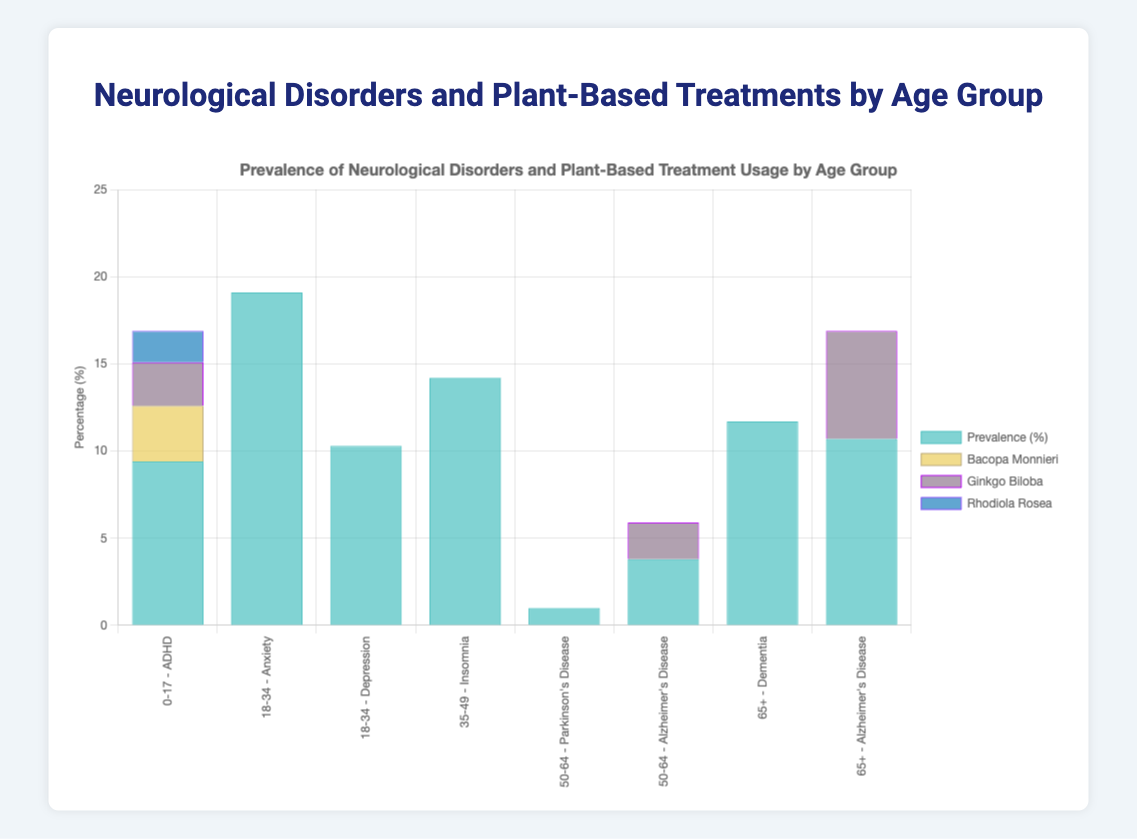What is the prevalence (%) of Anxiety in the 18-34 age group? Look at the bar corresponding to the 18-34 age group with the label "Anxiety." The height of the blue section of the bar indicates the prevalence.
Answer: 19.1 Which disorder has the highest plant-based treatment usage rate in the 50-64 age group? Compare the different treatment usage rates within the three plant-based compounds for the age group 50-64. The tallest segment in these bars corresponds to Ginkgo Biloba for Alzheimer's Disease.
Answer: Ginkgo Biloba for Alzheimer's Disease What is the total plant-based treatment usage (%) for ADHD in the 0-17 age group? Add up the individual percentages for Bacopa Monnieri, Ginkgo Biloba, and Rhodiola Rosea in the 0-17 age group. 3.2 + 2.5 + 1.8 = 7.5.
Answer: 7.5 In the 65+ age group, which plant-based treatment is used more for Alzheimer's Disease, Ginkgo Biloba or Huperzine A? Look at the respective segments for Ginkgo Biloba and Huperzine A within the 65+ age group bar for Alzheimer's Disease. The blue section (Ginkgo Biloba) is higher.
Answer: Ginkgo Biloba What is the difference in the prevalence (%) of Alzheimer's Disease between the 50-64 and 65+ age groups? Subtract the prevalence rate for the 50-64 age group from that of the 65+ age group. 10.7 - 3.8 = 6.9.
Answer: 6.9 Which plant-based treatment has the highest usage (%) for Anxiety in the 18-34 age group? Compare the heights of the segments within the Anxiety bar for the 18-34 age group. The tallest section (8.3) corresponds to Ashwagandha.
Answer: Ashwagandha Which age group has the highest prevalence of neurological disorders and which disorder is it? Identify the bar with the highest blue section among all the age groups. The tallest blue section corresponds to Anxiety in the 18-34 age group with 19.1.
Answer: 18-34, Anxiety Compare the prevalence of Alzheimer's Disease and Dementia in the 65+ age group. Which is higher and by how much? Compare the blue sections for Alzheimer's Disease and Dementia in the 65+ age group. Alzheimer's is 10.7 and Dementia is 11.7. The difference is 11.7 - 10.7 = 1.0.
Answer: Dementia, 1.0 Which plant-based treatment is used less for Parkinson's Disease than for Alzheimer's Disease in the 50-64 age group? Compare the usage rates of Mucuna Pruriens, Green Tea Extract, and Curcumin in the Parkinson's Disease bar to the usage rates of Ginkgo Biloba, Huperzine A, and Omega-3 Fatty Acids in the Alzheimer's Disease bar for the 50-64 age group. Each plant-based treatment (Ginkgo Biloba 2.1, Huperzine A 1.7, Omega-3 Fatty Acids 1.0) has higher usage compared to Mucuna Pruriens (0.6), Green Tea Extract (0.4), and Curcumin (0.3). Hence all treatments in Alzheimer's are more used.
Answer: Mucuna Pruriens, Green Tea Extract, Curcumin 